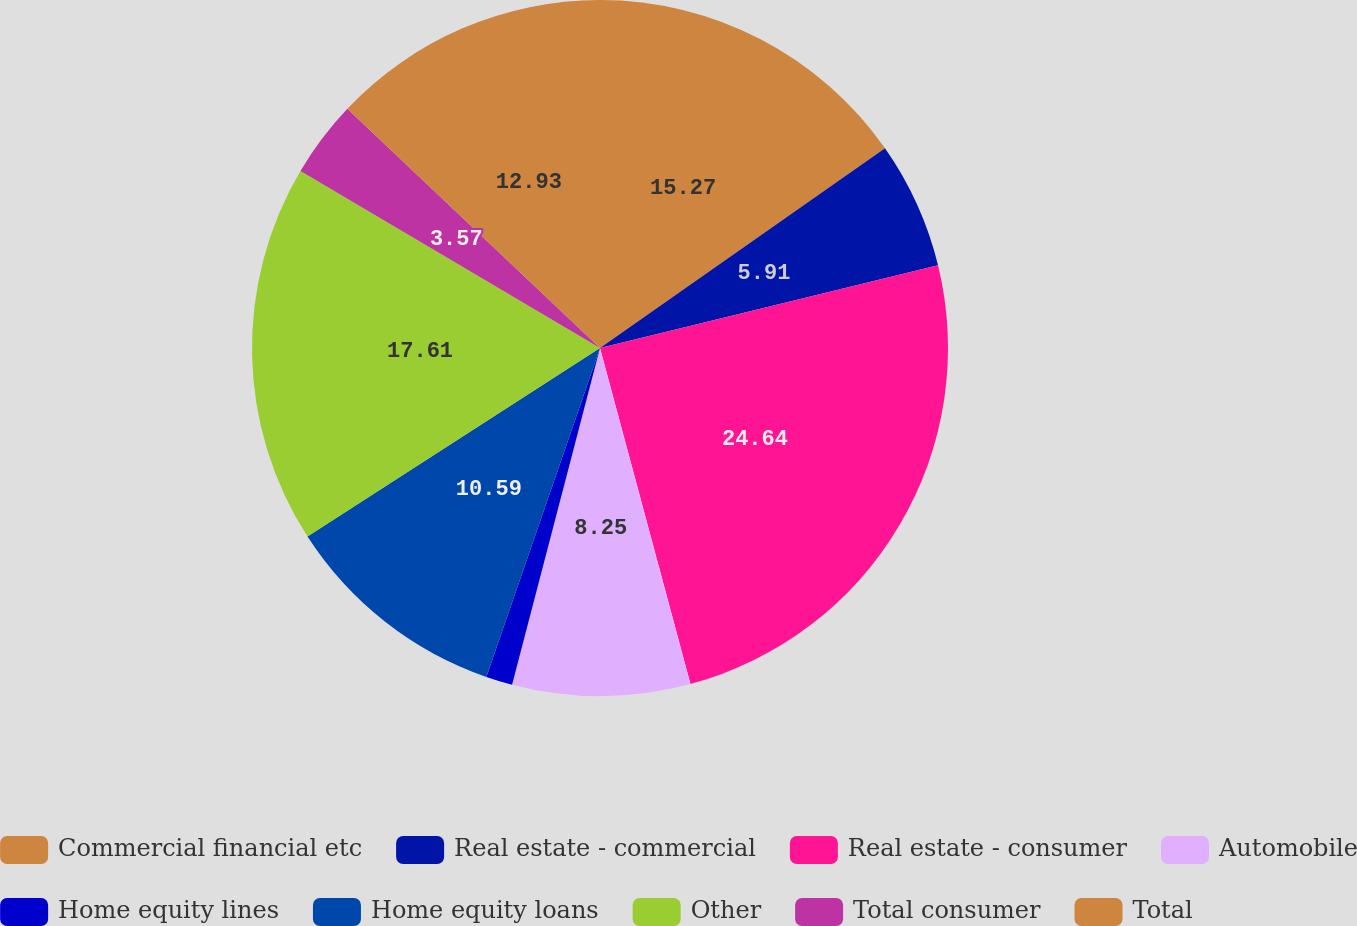Convert chart to OTSL. <chart><loc_0><loc_0><loc_500><loc_500><pie_chart><fcel>Commercial financial etc<fcel>Real estate - commercial<fcel>Real estate - consumer<fcel>Automobile<fcel>Home equity lines<fcel>Home equity loans<fcel>Other<fcel>Total consumer<fcel>Total<nl><fcel>15.27%<fcel>5.91%<fcel>24.63%<fcel>8.25%<fcel>1.23%<fcel>10.59%<fcel>17.61%<fcel>3.57%<fcel>12.93%<nl></chart> 